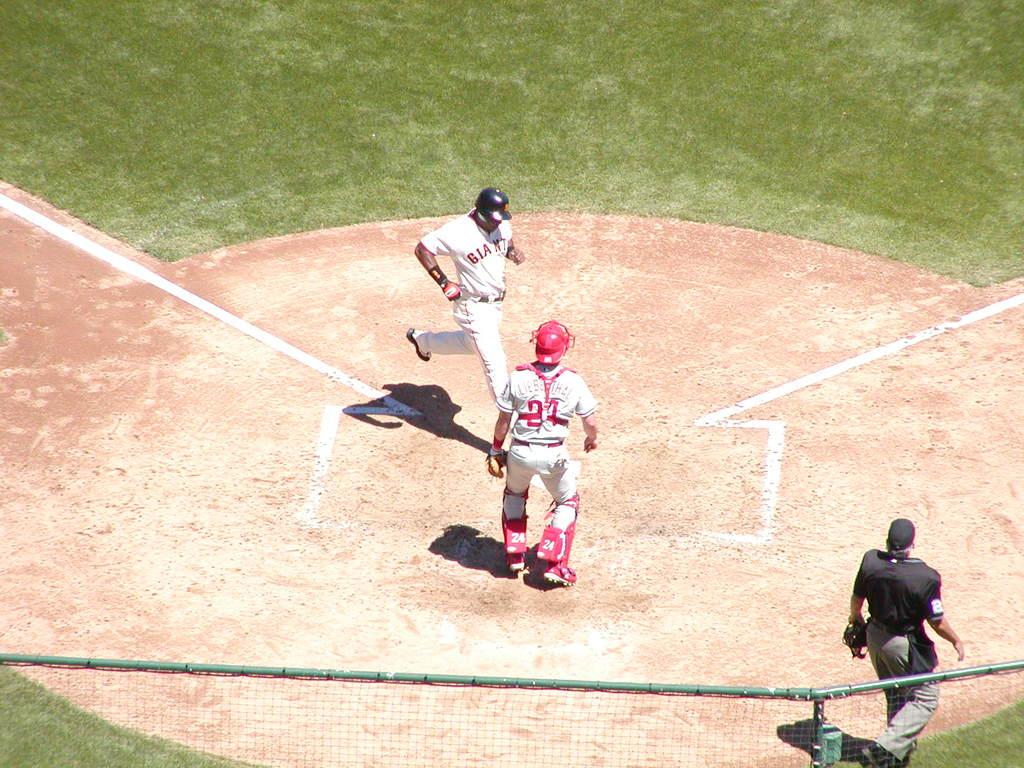<image>
Summarize the visual content of the image. A player runs the bases in a Giants uniform. 